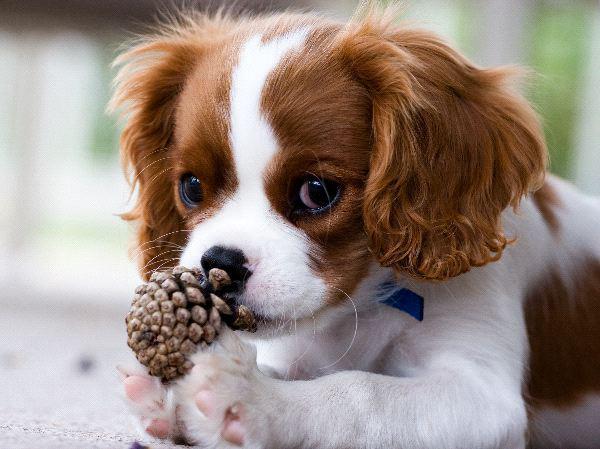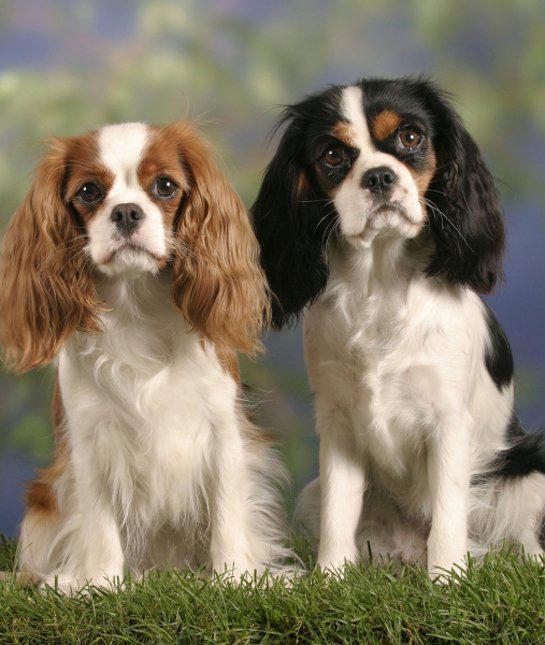The first image is the image on the left, the second image is the image on the right. Evaluate the accuracy of this statement regarding the images: "There is exactly three dogs in the right image.". Is it true? Answer yes or no. No. The first image is the image on the left, the second image is the image on the right. Analyze the images presented: Is the assertion "There are three dogs in one image and two in another." valid? Answer yes or no. No. 